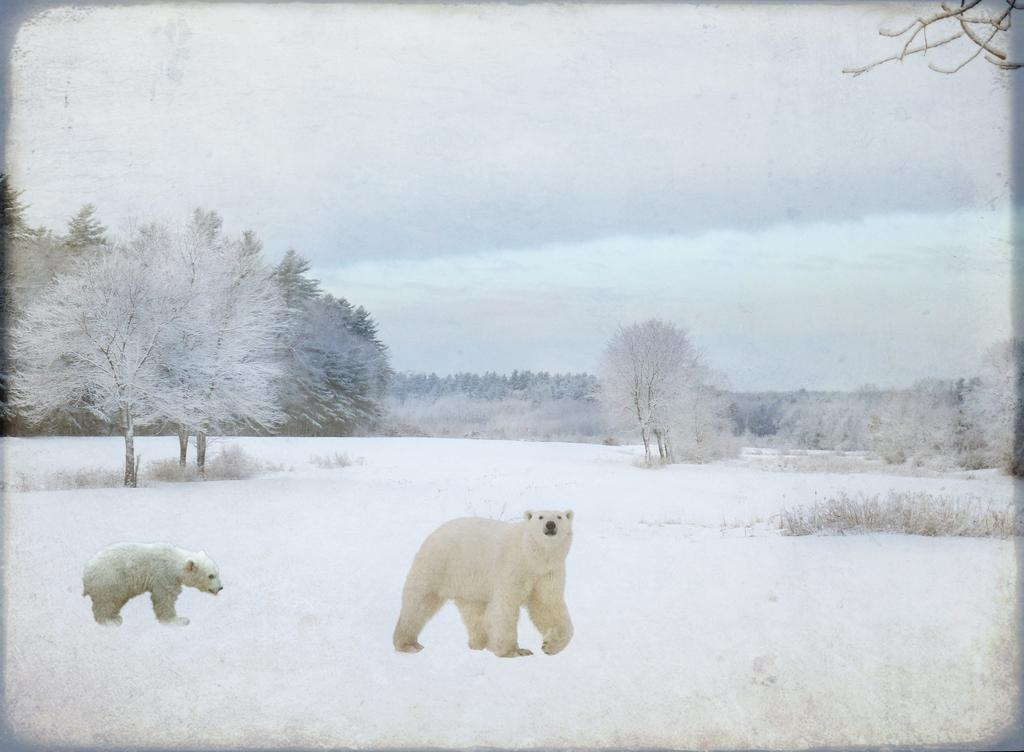What is the main subject of the image? The image contains a photo. What types of living organisms can be seen in the photo? Animals are visible in the photo. What is the terrain on which the animals are situated? The animals are on grass. What is visible at the top of the photo? The sky is visible at the top of the photo. What type of vegetation is present in the photo? Trees are present in the photo. What type of plants can be seen growing inside the goose's brain in the image? There is no goose or brain present in the image, and therefore no such plants can be observed. 